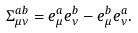<formula> <loc_0><loc_0><loc_500><loc_500>\Sigma _ { \mu \nu } ^ { a b } = e _ { \mu } ^ { a } e _ { \nu } ^ { b } - e _ { \mu } ^ { b } e _ { \nu } ^ { a } .</formula> 